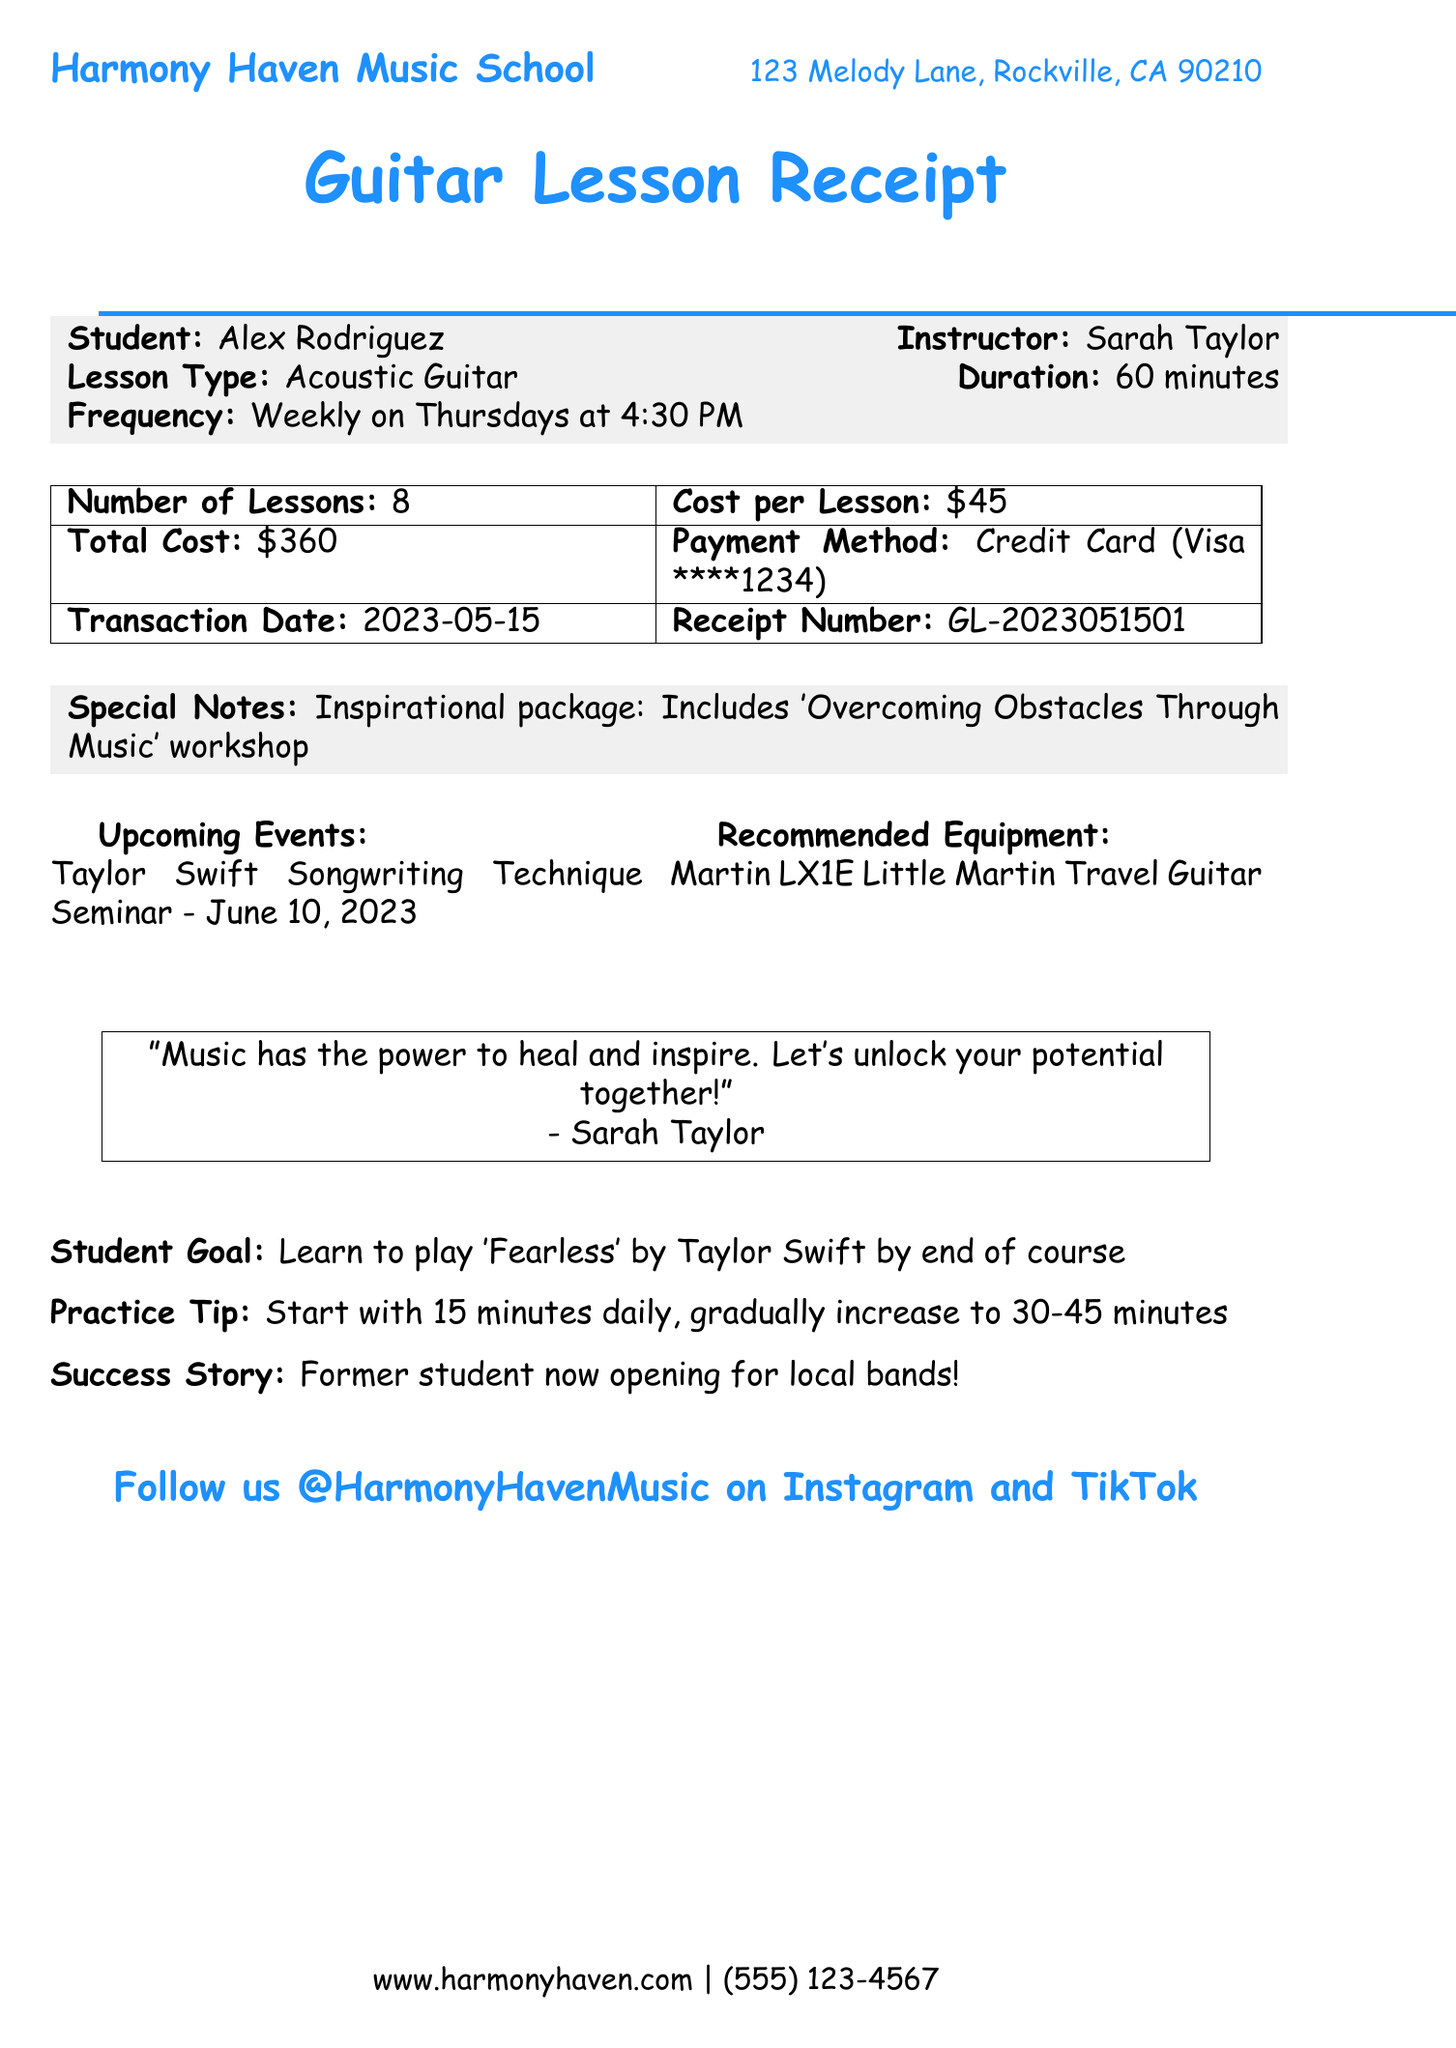What is the name of the music school? The name of the music school is indicated at the top of the document.
Answer: Harmony Haven Music School What is the address of the music school? The address is listed in the header of the document.
Answer: 123 Melody Lane, Rockville, CA 90210 Who is the instructor for the guitar lessons? The instructor's name is provided in the student-instructor section of the receipt.
Answer: Sarah Taylor What is the total cost of the lessons? The total cost is specified in the costs table of the document.
Answer: $360 How many lessons are included in this receipt? The number of lessons is mentioned in the tabular section of the receipt.
Answer: 8 What is the lesson frequency? The frequency of the lessons is mentioned in the student-instructor section.
Answer: Weekly What is the payment method used? The payment method is provided along with the transaction details in the cost table.
Answer: Credit Card What goal does the student have for their guitar lessons? The student's goal is stated in the goal section of the document.
Answer: Learn to play 'Fearless' by Taylor Swift by end of course What workshop is included in the special notes? The workshop is noted in the special notes section of the receipt.
Answer: Overcoming Obstacles Through Music What is the upcoming event mentioned in the document? The upcoming event is specified in the events section of the receipt.
Answer: Taylor Swift Songwriting Technique Seminar - June 10, 2023 